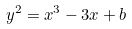<formula> <loc_0><loc_0><loc_500><loc_500>y ^ { 2 } = x ^ { 3 } - 3 x + b</formula> 